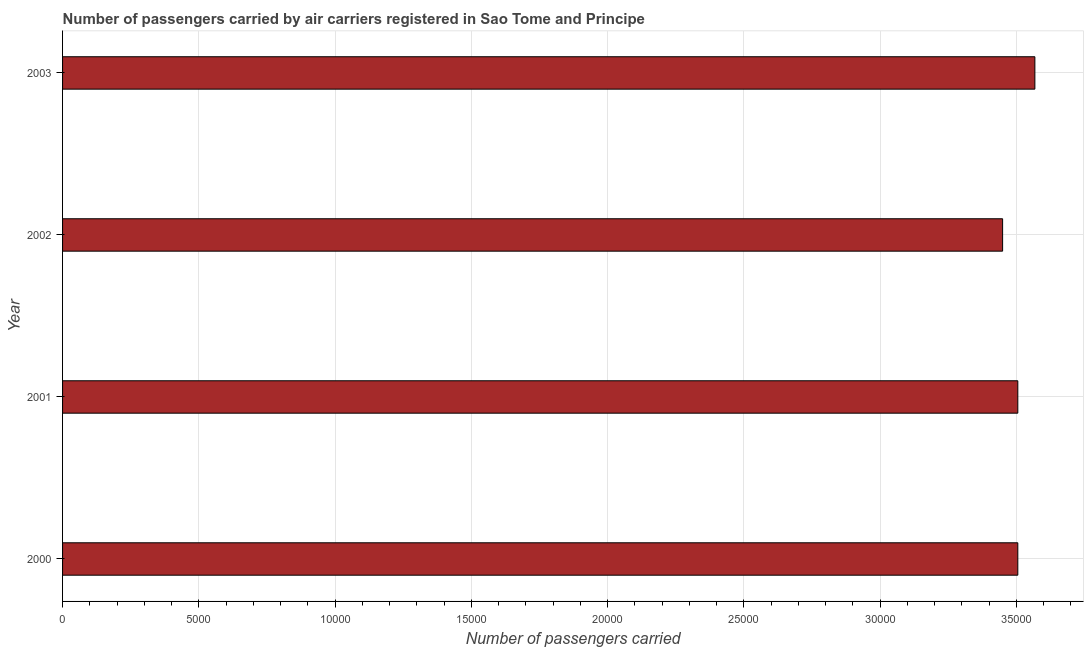Does the graph contain grids?
Offer a very short reply. Yes. What is the title of the graph?
Your answer should be very brief. Number of passengers carried by air carriers registered in Sao Tome and Principe. What is the label or title of the X-axis?
Keep it short and to the point. Number of passengers carried. What is the number of passengers carried in 2003?
Give a very brief answer. 3.57e+04. Across all years, what is the maximum number of passengers carried?
Ensure brevity in your answer.  3.57e+04. Across all years, what is the minimum number of passengers carried?
Provide a succinct answer. 3.45e+04. In which year was the number of passengers carried minimum?
Your response must be concise. 2002. What is the sum of the number of passengers carried?
Your answer should be very brief. 1.40e+05. What is the average number of passengers carried per year?
Your answer should be very brief. 3.51e+04. What is the median number of passengers carried?
Offer a terse response. 3.51e+04. In how many years, is the number of passengers carried greater than 35000 ?
Provide a short and direct response. 3. What is the ratio of the number of passengers carried in 2000 to that in 2003?
Your answer should be very brief. 0.98. Is the number of passengers carried in 2000 less than that in 2001?
Your answer should be compact. No. Is the difference between the number of passengers carried in 2000 and 2001 greater than the difference between any two years?
Give a very brief answer. No. What is the difference between the highest and the second highest number of passengers carried?
Keep it short and to the point. 626. Is the sum of the number of passengers carried in 2000 and 2002 greater than the maximum number of passengers carried across all years?
Give a very brief answer. Yes. What is the difference between the highest and the lowest number of passengers carried?
Ensure brevity in your answer.  1184. How many bars are there?
Your answer should be very brief. 4. Are all the bars in the graph horizontal?
Give a very brief answer. Yes. What is the Number of passengers carried in 2000?
Give a very brief answer. 3.51e+04. What is the Number of passengers carried in 2001?
Make the answer very short. 3.51e+04. What is the Number of passengers carried in 2002?
Offer a very short reply. 3.45e+04. What is the Number of passengers carried of 2003?
Offer a very short reply. 3.57e+04. What is the difference between the Number of passengers carried in 2000 and 2002?
Keep it short and to the point. 558. What is the difference between the Number of passengers carried in 2000 and 2003?
Keep it short and to the point. -626. What is the difference between the Number of passengers carried in 2001 and 2002?
Provide a succinct answer. 558. What is the difference between the Number of passengers carried in 2001 and 2003?
Your response must be concise. -626. What is the difference between the Number of passengers carried in 2002 and 2003?
Offer a very short reply. -1184. What is the ratio of the Number of passengers carried in 2000 to that in 2002?
Provide a succinct answer. 1.02. 